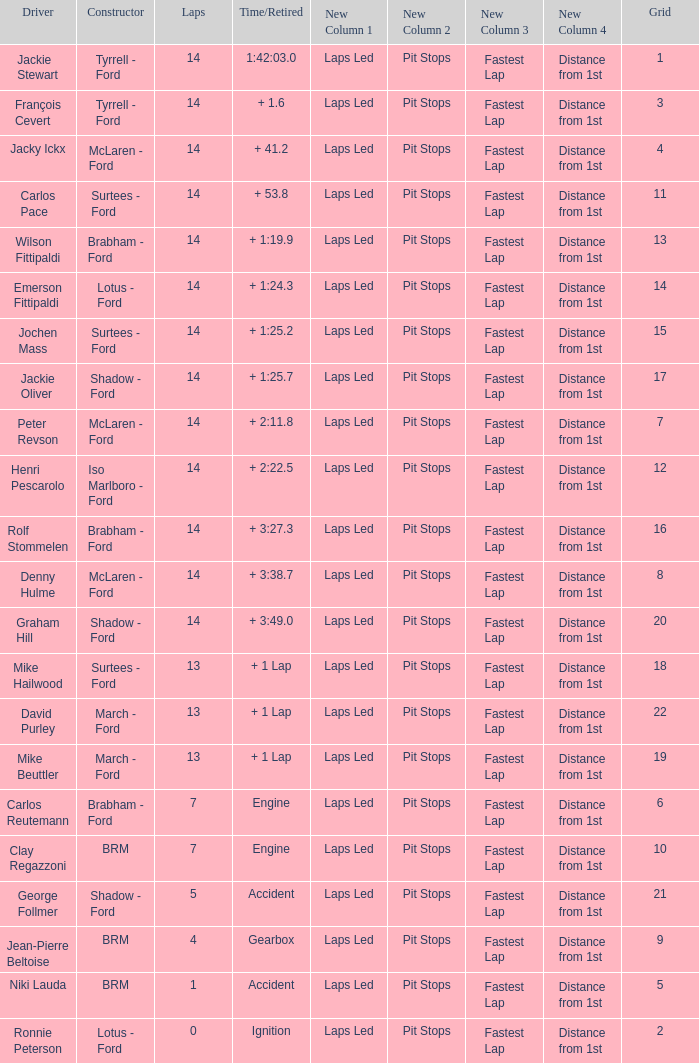What grad has a Time/Retired of + 1:24.3? 14.0. 